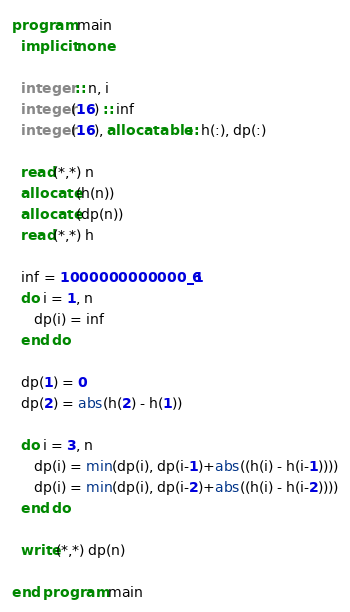Convert code to text. <code><loc_0><loc_0><loc_500><loc_500><_FORTRAN_>program main
  implicit none

  integer :: n, i
  integer(16) :: inf
  integer(16), allocatable :: h(:), dp(:)

  read(*,*) n
  allocate(h(n))
  allocate(dp(n))
  read(*,*) h

  inf = 1000000000000_16
  do i = 1, n
     dp(i) = inf
  end do

  dp(1) = 0
  dp(2) = abs(h(2) - h(1))

  do i = 3, n
     dp(i) = min(dp(i), dp(i-1)+abs((h(i) - h(i-1))))
     dp(i) = min(dp(i), dp(i-2)+abs((h(i) - h(i-2))))
  end do

  write(*,*) dp(n)

end program main
</code> 